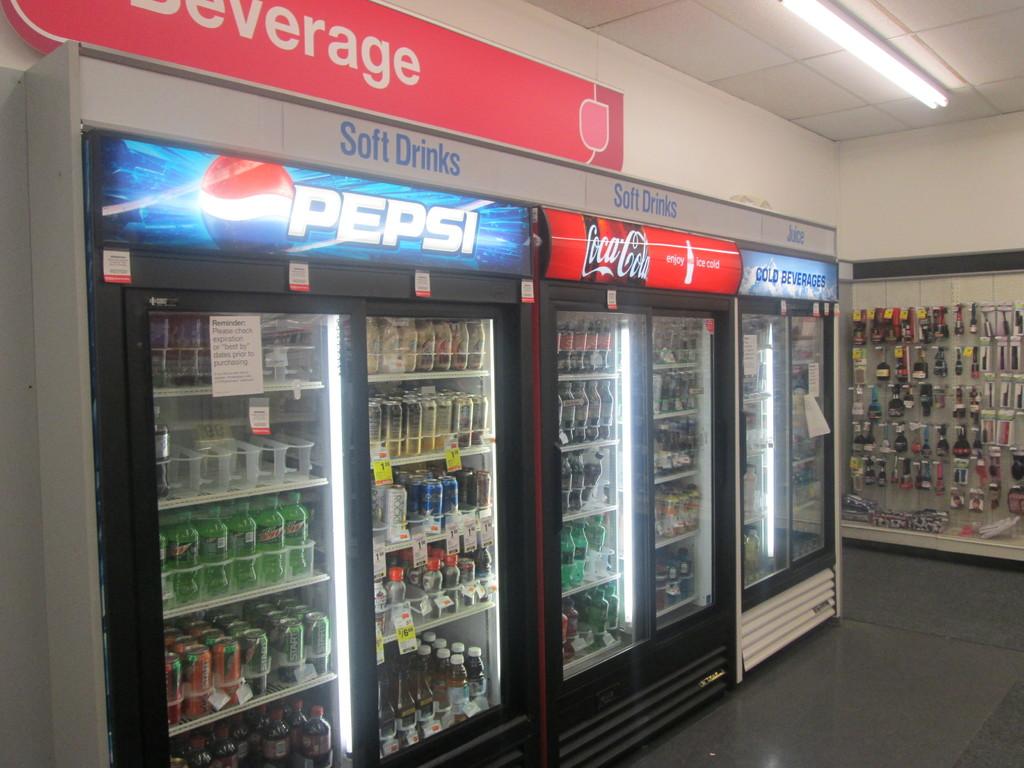What's the product name over the middle fridge?
Provide a succinct answer. Coca-cola. 